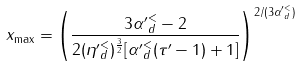Convert formula to latex. <formula><loc_0><loc_0><loc_500><loc_500>x _ { \max } = \left ( \frac { 3 { \alpha ^ { \prime } } _ { d } ^ { < } - 2 } { 2 ( { \eta ^ { \prime } } ^ { < } _ { d } ) ^ { \frac { 3 } { 2 } } [ { \alpha ^ { \prime } } _ { d } ^ { < } ( \tau ^ { \prime } - 1 ) + 1 ] } \right ) ^ { 2 / ( 3 { \alpha ^ { \prime } } _ { d } ^ { < } ) }</formula> 